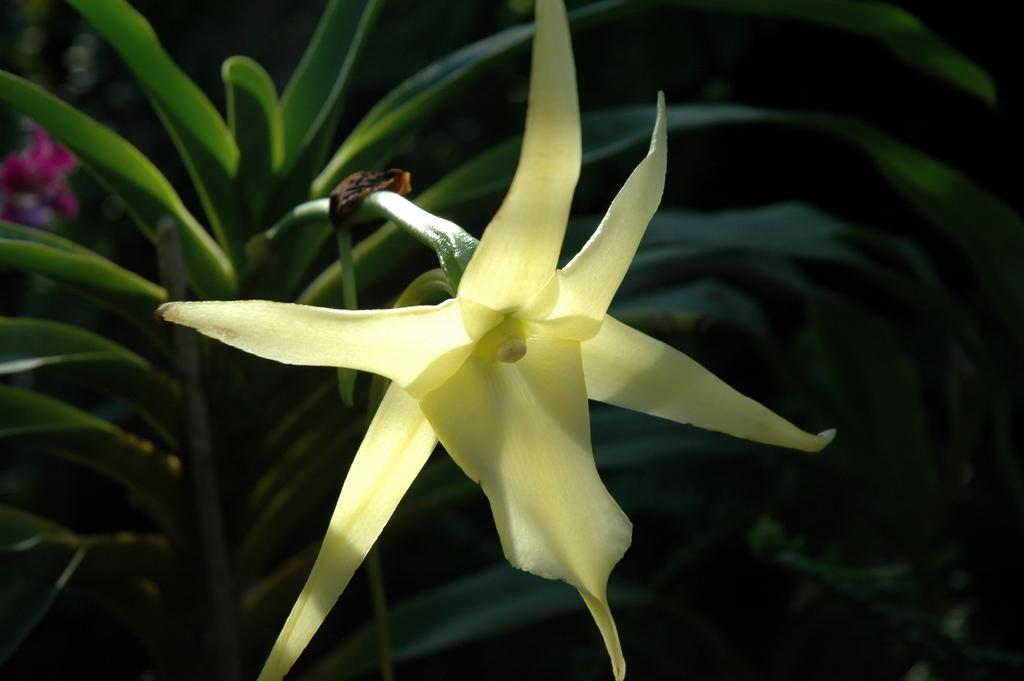What type of living organisms can be seen in the image? Plants can be seen in the image. Is there any specific feature on one of the plants? Yes, there is a flower on one of the plants. What else can be found on one of the plants? There is an object on one of the plants. What type of shop can be seen in the image? There is no shop present in the image; it features plants with a flower and an object. What organization is responsible for the arrangement of the plants in the image? There is no organization mentioned or implied in the image; it simply shows plants with a flower and an object. 